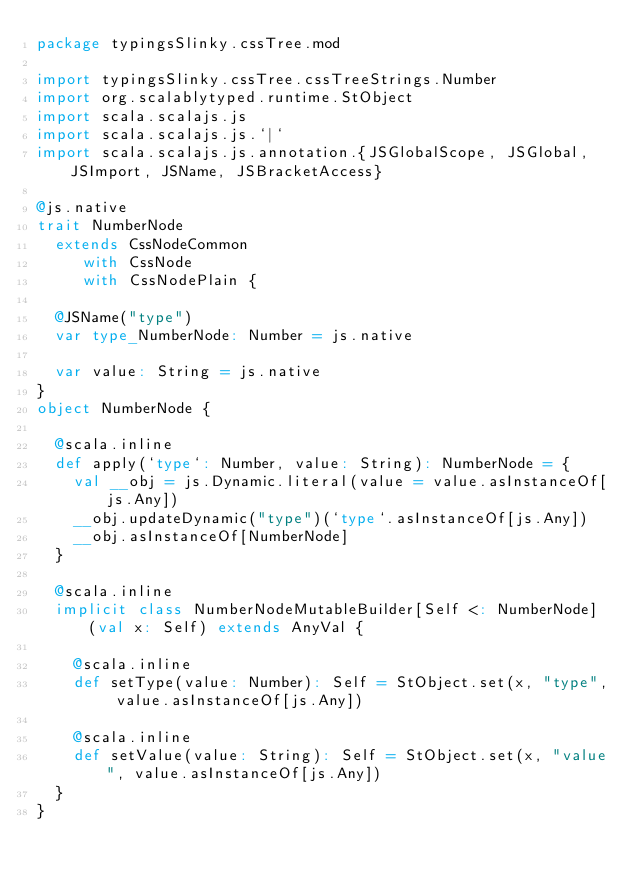<code> <loc_0><loc_0><loc_500><loc_500><_Scala_>package typingsSlinky.cssTree.mod

import typingsSlinky.cssTree.cssTreeStrings.Number
import org.scalablytyped.runtime.StObject
import scala.scalajs.js
import scala.scalajs.js.`|`
import scala.scalajs.js.annotation.{JSGlobalScope, JSGlobal, JSImport, JSName, JSBracketAccess}

@js.native
trait NumberNode
  extends CssNodeCommon
     with CssNode
     with CssNodePlain {
  
  @JSName("type")
  var type_NumberNode: Number = js.native
  
  var value: String = js.native
}
object NumberNode {
  
  @scala.inline
  def apply(`type`: Number, value: String): NumberNode = {
    val __obj = js.Dynamic.literal(value = value.asInstanceOf[js.Any])
    __obj.updateDynamic("type")(`type`.asInstanceOf[js.Any])
    __obj.asInstanceOf[NumberNode]
  }
  
  @scala.inline
  implicit class NumberNodeMutableBuilder[Self <: NumberNode] (val x: Self) extends AnyVal {
    
    @scala.inline
    def setType(value: Number): Self = StObject.set(x, "type", value.asInstanceOf[js.Any])
    
    @scala.inline
    def setValue(value: String): Self = StObject.set(x, "value", value.asInstanceOf[js.Any])
  }
}
</code> 